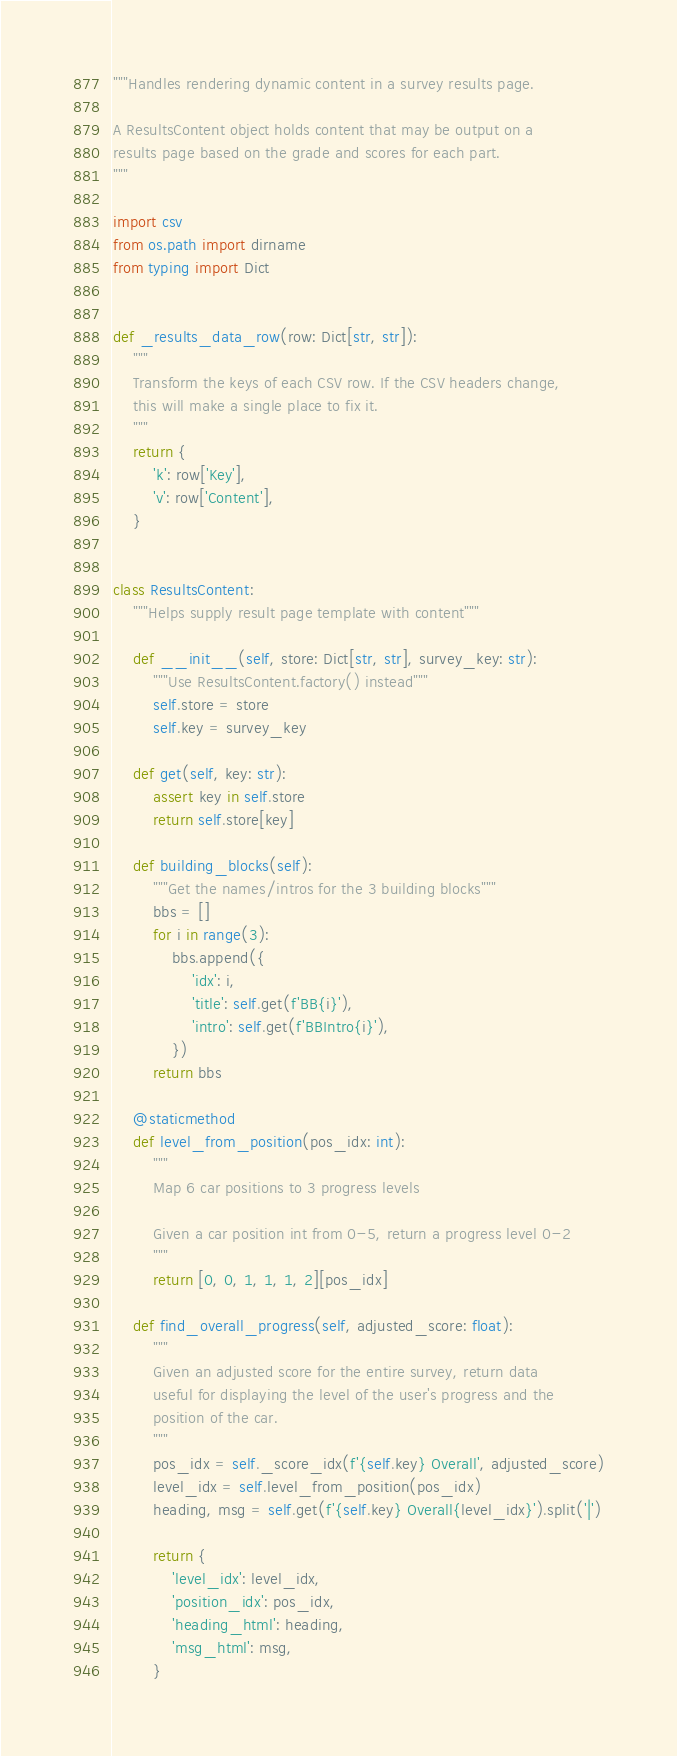<code> <loc_0><loc_0><loc_500><loc_500><_Python_>"""Handles rendering dynamic content in a survey results page.

A ResultsContent object holds content that may be output on a
results page based on the grade and scores for each part.
"""

import csv
from os.path import dirname
from typing import Dict


def _results_data_row(row: Dict[str, str]):
    """
    Transform the keys of each CSV row. If the CSV headers change,
    this will make a single place to fix it.
    """
    return {
        'k': row['Key'],
        'v': row['Content'],
    }


class ResultsContent:
    """Helps supply result page template with content"""

    def __init__(self, store: Dict[str, str], survey_key: str):
        """Use ResultsContent.factory() instead"""
        self.store = store
        self.key = survey_key

    def get(self, key: str):
        assert key in self.store
        return self.store[key]

    def building_blocks(self):
        """Get the names/intros for the 3 building blocks"""
        bbs = []
        for i in range(3):
            bbs.append({
                'idx': i,
                'title': self.get(f'BB{i}'),
                'intro': self.get(f'BBIntro{i}'),
            })
        return bbs

    @staticmethod
    def level_from_position(pos_idx: int):
        """
        Map 6 car positions to 3 progress levels

        Given a car position int from 0-5, return a progress level 0-2
        """
        return [0, 0, 1, 1, 1, 2][pos_idx]

    def find_overall_progress(self, adjusted_score: float):
        """
        Given an adjusted score for the entire survey, return data
        useful for displaying the level of the user's progress and the
        position of the car.
        """
        pos_idx = self._score_idx(f'{self.key} Overall', adjusted_score)
        level_idx = self.level_from_position(pos_idx)
        heading, msg = self.get(f'{self.key} Overall{level_idx}').split('|')

        return {
            'level_idx': level_idx,
            'position_idx': pos_idx,
            'heading_html': heading,
            'msg_html': msg,
        }
</code> 